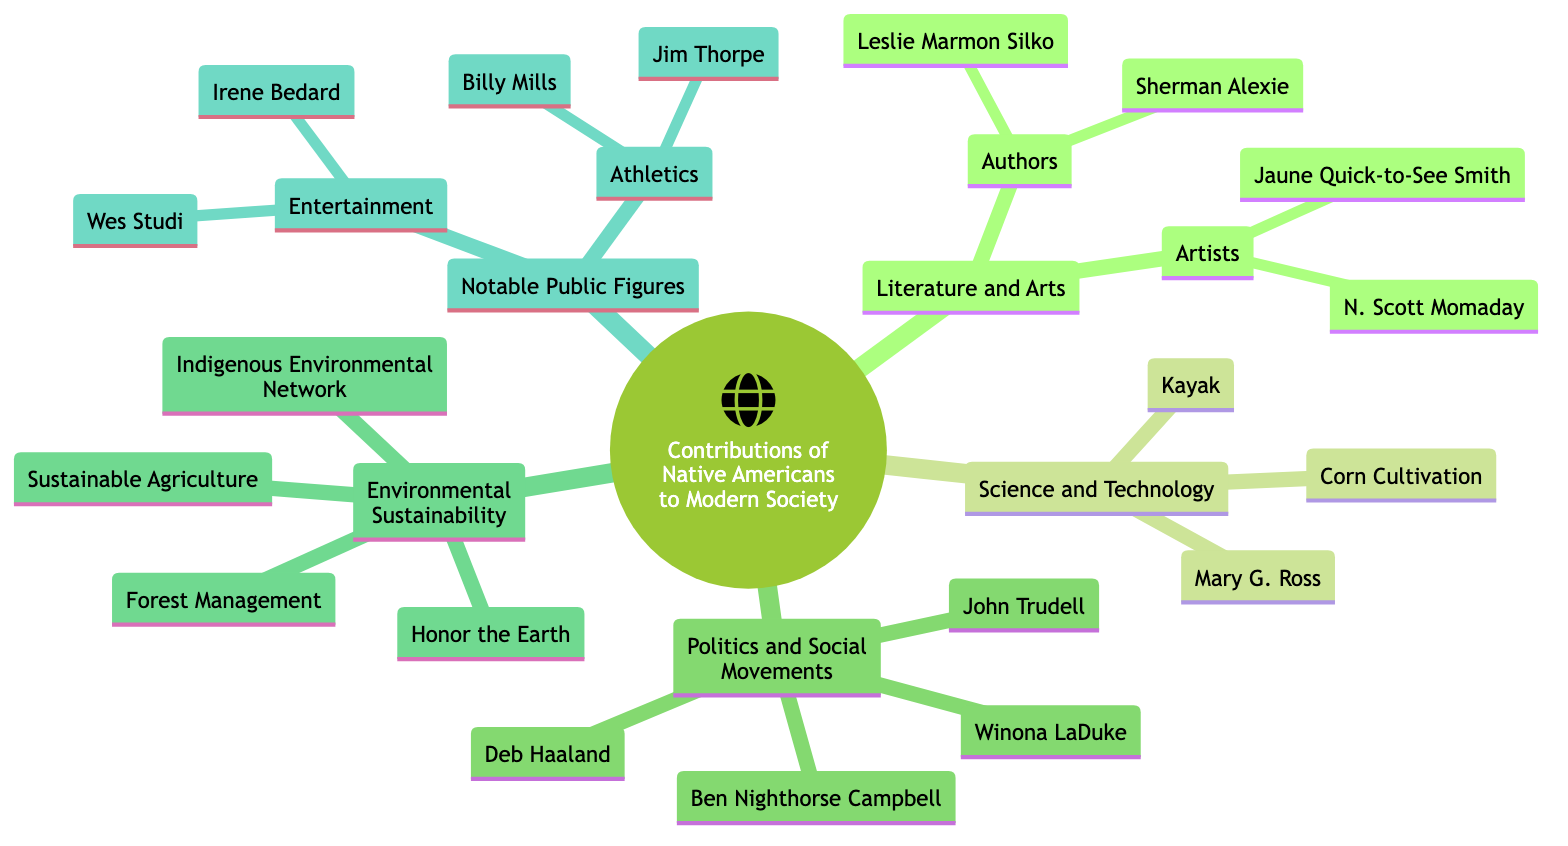What are two notable works by Sherman Alexie? The diagram lists Sherman Alexie under the "Authors" section in "Achievements in Literature and Arts" and associates him with the works "The Lone Ranger and Tonto Fistfight in Heaven" and "The Absolutely True Diary of a Part-Time Indian".
Answer: The Lone Ranger and Tonto Fistfight in Heaven, The Absolutely True Diary of a Part-Time Indian Who is the founder of Honor the Earth? The "Organizations" section under "Contributions to Environmental Sustainability" identifies Winona LaDuke as the founder of Honor the Earth.
Answer: Winona LaDuke How many Political Leaders are mentioned in the diagram? The "Political Leaders" subsection under "Leadership in Politics and Social Movements" includes two names: Deb Haaland and Ben Nighthorse Campbell, indicating there are two political leaders.
Answer: 2 What is the innovation attributed to the Inuit people? Under "Technological Contributions" in "Innovations in Science and Technology," the kayak is listed as an innovation that originates from the Inuit people.
Answer: Kayak Which artist is known for achieving a Pulitzer Prize for Fiction? The diagram shows N. Scott Momaday listed under "Artists" in the "Achievements in Literature and Arts" section, noting his Pulitzer Prize for Fiction.
Answer: N. Scott Momaday What practice is described as the Three Sisters Crop System? The diagram categorizes the Three Sisters Crop System under "Sustainable Agriculture" within "Contributions to Environmental Sustainability."
Answer: Sustainable Agriculture How many social activists are mentioned in the document? The "Social Activists" subsection under "Leadership in Politics and Social Movements" mentions two individuals: Winona LaDuke and John Trudell, indicating there are two social activists listed.
Answer: 2 What field is Wes Studi associated with? From the "Entertainment" subsection in "Notable Public Figures," Wes Studi is categorized under acting.
Answer: Acting Which innovation involves corn cultivation techniques? In the "Technological Contributions" section under "Innovations in Science and Technology," corn cultivation techniques are specifically listed as an innovation from various Indigenous tribes.
Answer: Corn Cultivation Techniques 